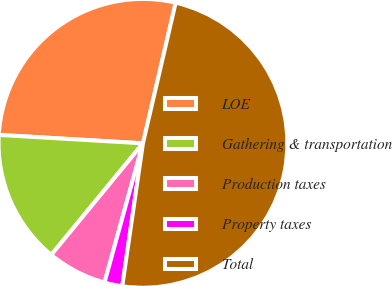<chart> <loc_0><loc_0><loc_500><loc_500><pie_chart><fcel>LOE<fcel>Gathering & transportation<fcel>Production taxes<fcel>Property taxes<fcel>Total<nl><fcel>27.71%<fcel>14.98%<fcel>6.66%<fcel>2.0%<fcel>48.65%<nl></chart> 